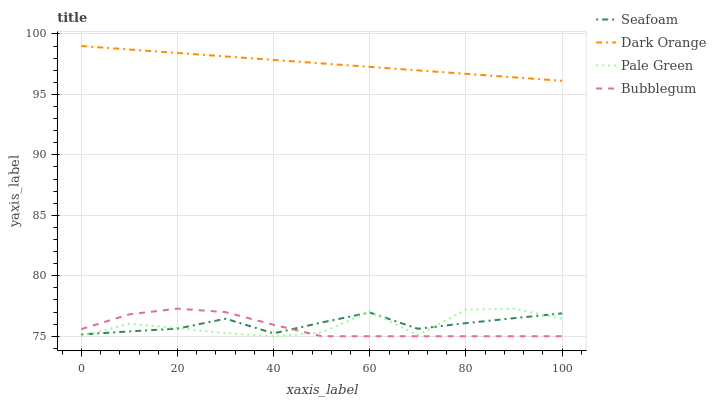Does Bubblegum have the minimum area under the curve?
Answer yes or no. Yes. Does Dark Orange have the maximum area under the curve?
Answer yes or no. Yes. Does Pale Green have the minimum area under the curve?
Answer yes or no. No. Does Pale Green have the maximum area under the curve?
Answer yes or no. No. Is Dark Orange the smoothest?
Answer yes or no. Yes. Is Pale Green the roughest?
Answer yes or no. Yes. Is Seafoam the smoothest?
Answer yes or no. No. Is Seafoam the roughest?
Answer yes or no. No. Does Pale Green have the lowest value?
Answer yes or no. Yes. Does Seafoam have the lowest value?
Answer yes or no. No. Does Dark Orange have the highest value?
Answer yes or no. Yes. Does Pale Green have the highest value?
Answer yes or no. No. Is Seafoam less than Dark Orange?
Answer yes or no. Yes. Is Dark Orange greater than Bubblegum?
Answer yes or no. Yes. Does Pale Green intersect Seafoam?
Answer yes or no. Yes. Is Pale Green less than Seafoam?
Answer yes or no. No. Is Pale Green greater than Seafoam?
Answer yes or no. No. Does Seafoam intersect Dark Orange?
Answer yes or no. No. 